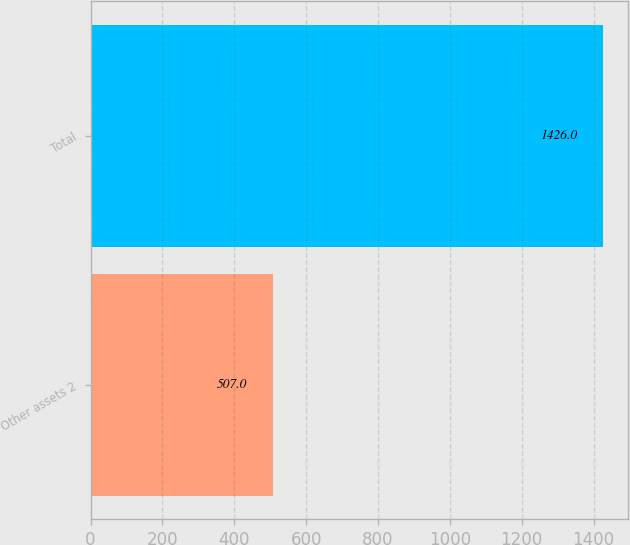<chart> <loc_0><loc_0><loc_500><loc_500><bar_chart><fcel>Other assets 2<fcel>Total<nl><fcel>507<fcel>1426<nl></chart> 